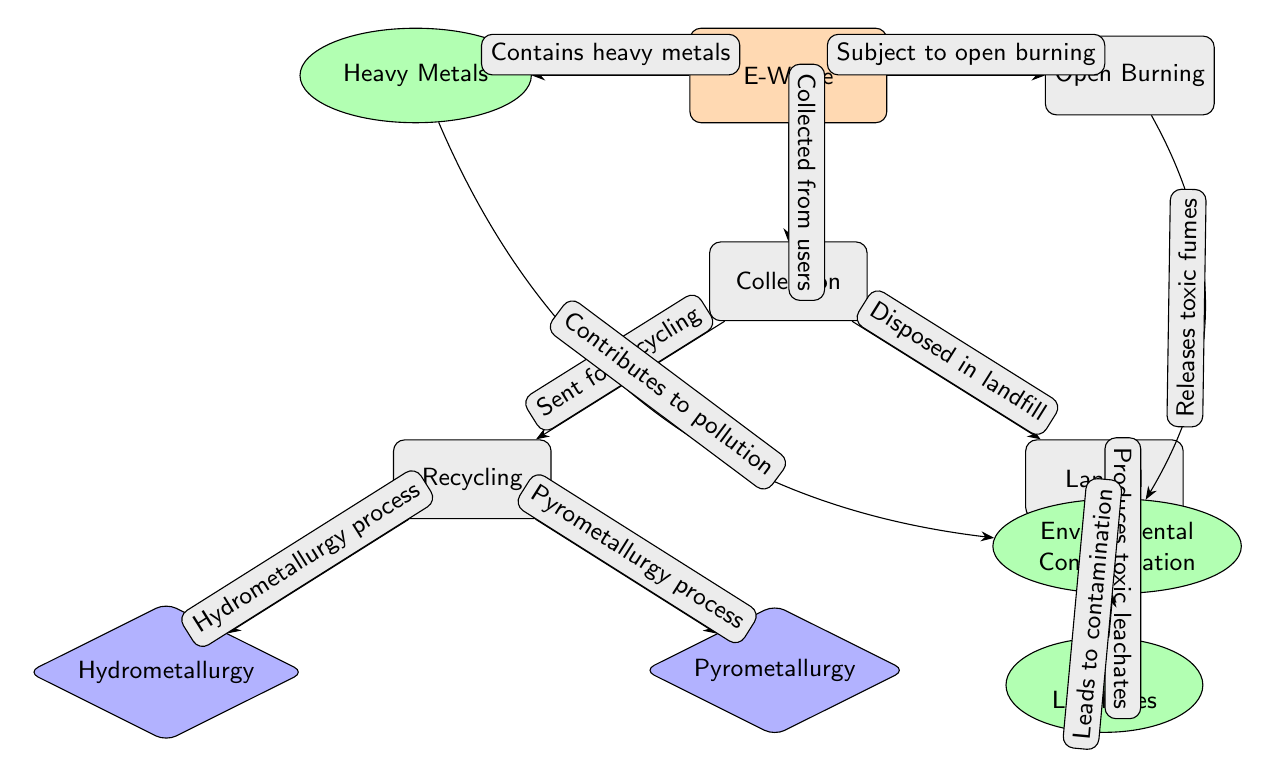What is the first process after E-Waste is collected? The diagram shows that after E-Waste is collected, it goes to the Collection process. This is the first node immediately below the E-Waste node.
Answer: Collection How many chemical processes are shown in the diagram? The diagram contains two chemical processes: Hydrometallurgy and Pyrometallurgy, both connected to the Recycling process node. Counting these nodes gives a total of two.
Answer: 2 What environmental issue results from landfill disposal of E-Waste? The diagram indicates that landfill disposal of E-Waste produces toxic leachates, which is the specific environmental issue specified in the flow.
Answer: Toxic Leachates Which process is directly connected to "Environmental Contamination"? The diagram demonstrates that both the Toxic Leachates and Open Burning are processes that lead directly to Environmental Contamination, making it necessary to consider both when answering the question.
Answer: Toxic Leachates, Open Burning What do heavy metals contribute to in the environment? The diagram shows that heavy metals contribute to pollution, which is stated in the edge connection leading from the Heavy Metals node to the Environmental Contamination node.
Answer: Pollution If E-Waste undergoes open burning, what do the fumes cause? According to the diagram, open burning releases toxic fumes which directly lead to Environmental Contamination. This is evident by the connection from the Open Burning node to the Environmental Contamination node.
Answer: Environmental Contamination Which process involves a hydrometallurgy approach? The diagram explicitly links the Recycling process to the hydrometallurgy method, labeling it as one of the pathways for recycling E-Waste.
Answer: Hydrometallurgy How do toxic leachates affect the environment? The diagram suggests that toxic leachates lead to contamination of the environment, as reflected by the edge connecting the Toxic Leachates node to the Environmental Contamination node.
Answer: Contamination 